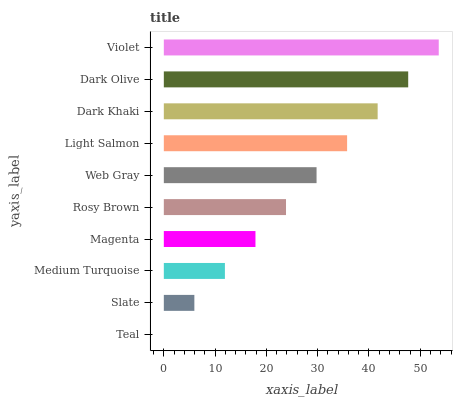Is Teal the minimum?
Answer yes or no. Yes. Is Violet the maximum?
Answer yes or no. Yes. Is Slate the minimum?
Answer yes or no. No. Is Slate the maximum?
Answer yes or no. No. Is Slate greater than Teal?
Answer yes or no. Yes. Is Teal less than Slate?
Answer yes or no. Yes. Is Teal greater than Slate?
Answer yes or no. No. Is Slate less than Teal?
Answer yes or no. No. Is Web Gray the high median?
Answer yes or no. Yes. Is Rosy Brown the low median?
Answer yes or no. Yes. Is Light Salmon the high median?
Answer yes or no. No. Is Magenta the low median?
Answer yes or no. No. 